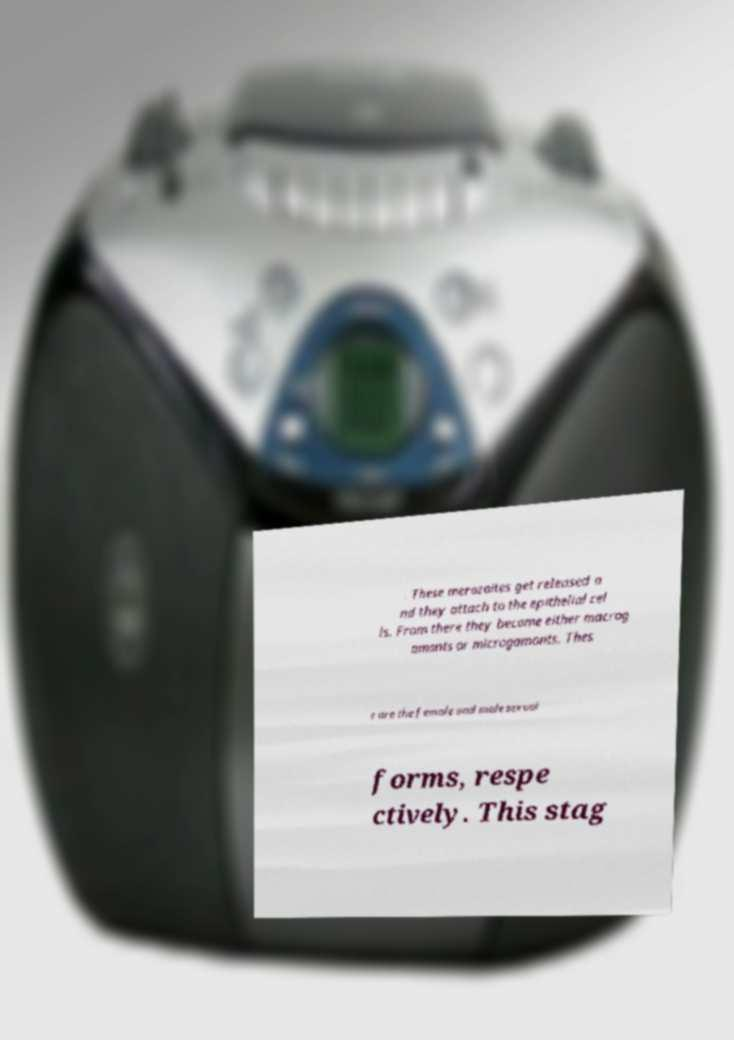There's text embedded in this image that I need extracted. Can you transcribe it verbatim? . These merozoites get released a nd they attach to the epithelial cel ls. From there they become either macrog amonts or microgamonts. Thes e are the female and male sexual forms, respe ctively. This stag 